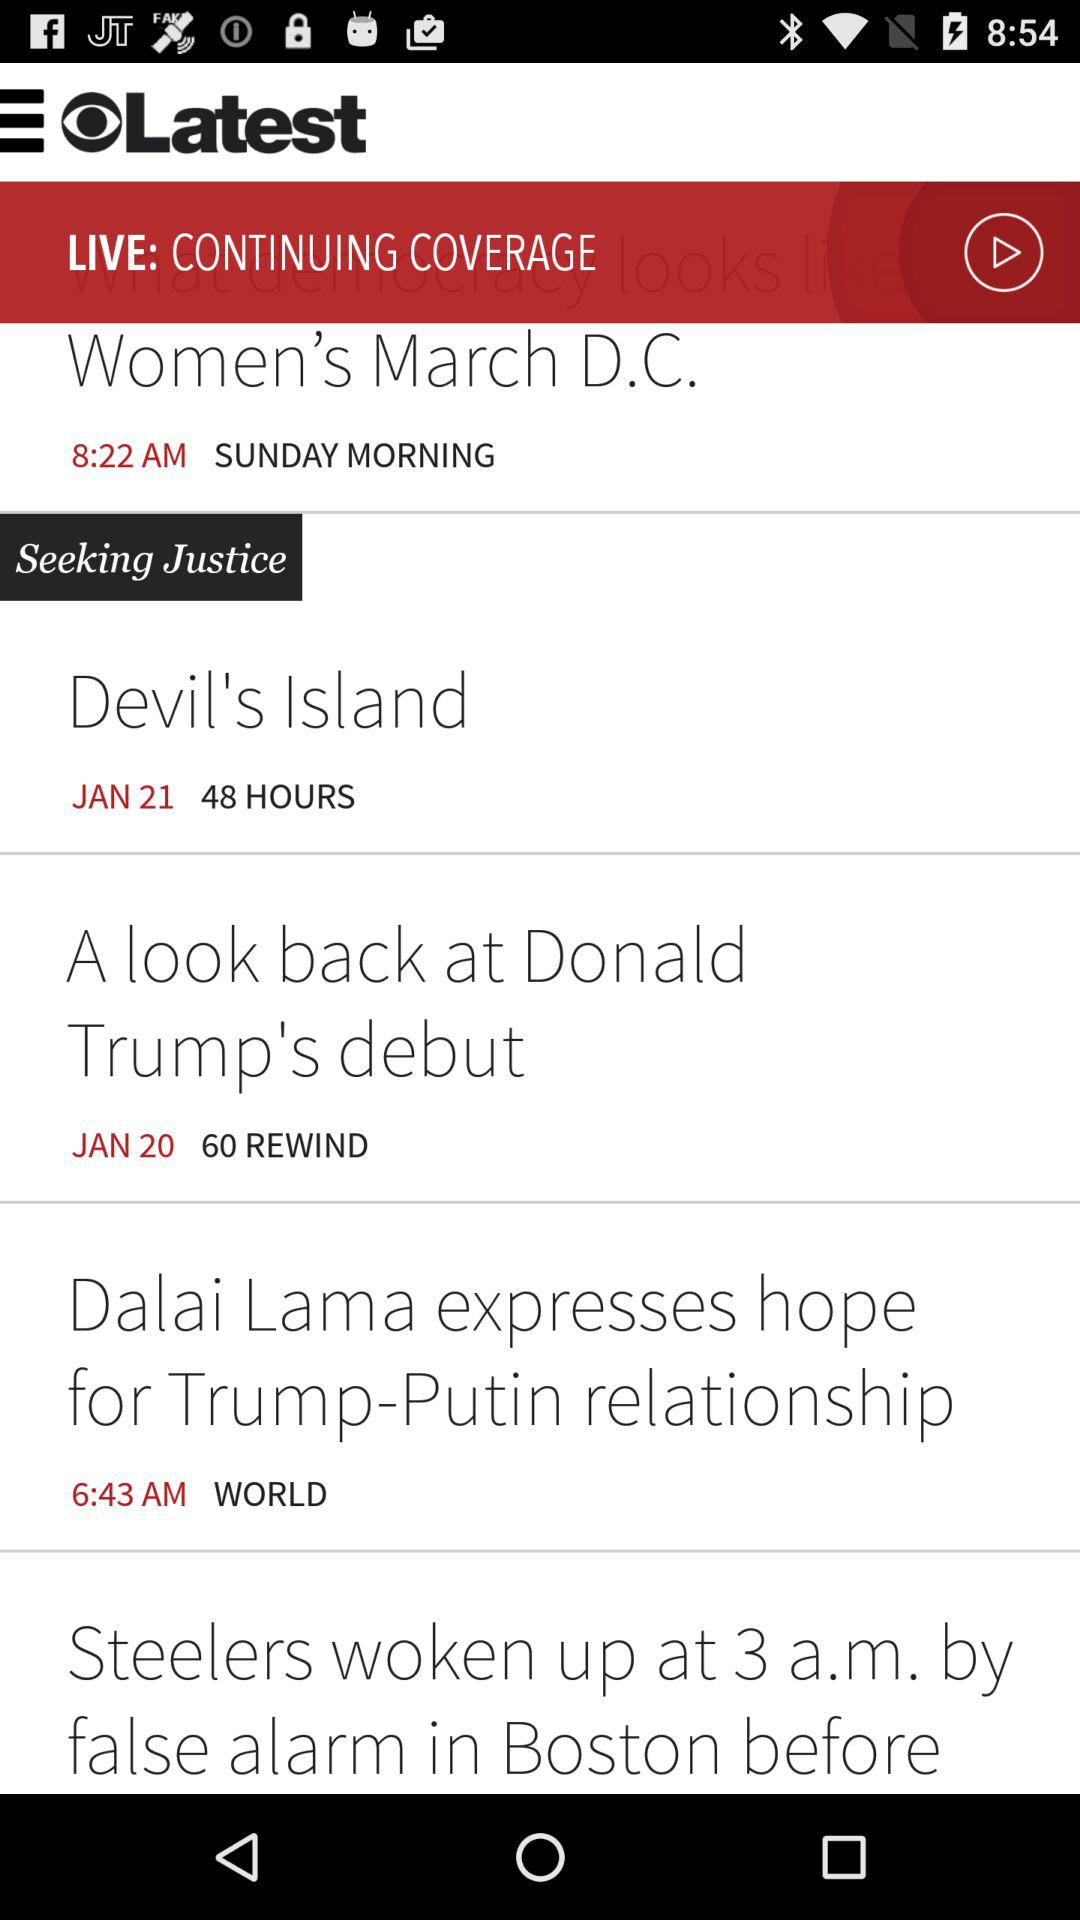When was the post "Women's March D.C." posted? The post "Women's March D.C." was posted on Sunday morning at 8:22 AM. 